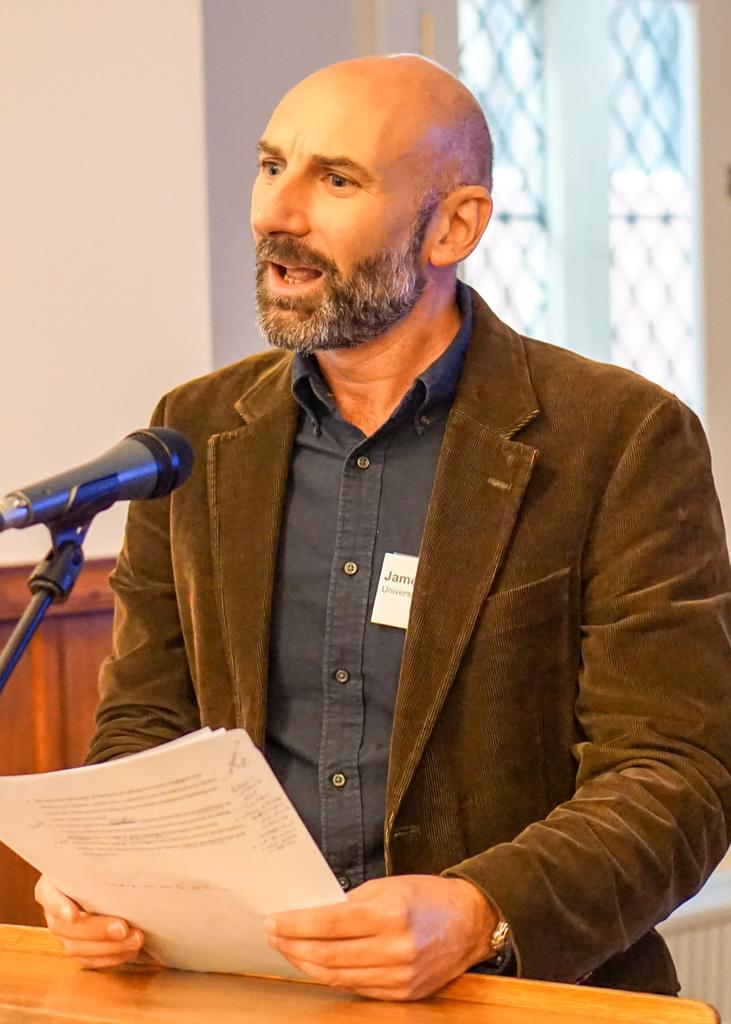What is the man in the image doing? The man is talking on a microphone. What is the man holding in his hands? The man is holding papers in his hands. What is present in the image for support or display? There is a table in the image. What can be seen in the background of the image? There is a wall and a window in the background of the image. Where is the sofa located in the image? There is no sofa present in the image. What type of house is depicted in the image? The image does not depict a house; it shows a man talking on a microphone. Can you tell me when the man's birthday is in the image? There is no information about the man's birthday in the image. 